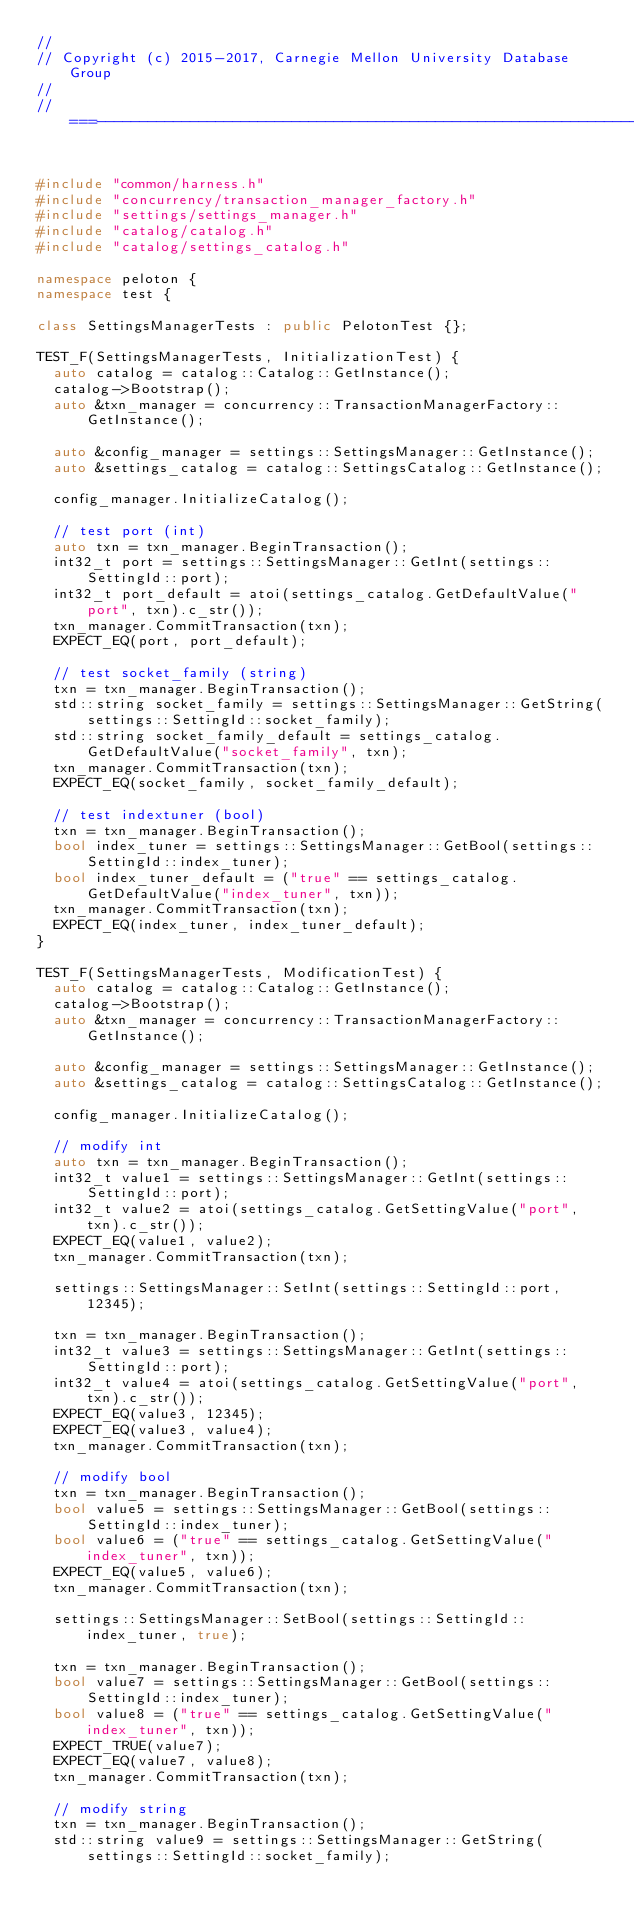<code> <loc_0><loc_0><loc_500><loc_500><_C++_>//
// Copyright (c) 2015-2017, Carnegie Mellon University Database Group
//
//===----------------------------------------------------------------------===//


#include "common/harness.h"
#include "concurrency/transaction_manager_factory.h"
#include "settings/settings_manager.h"
#include "catalog/catalog.h"
#include "catalog/settings_catalog.h"

namespace peloton {
namespace test {

class SettingsManagerTests : public PelotonTest {};

TEST_F(SettingsManagerTests, InitializationTest) {
  auto catalog = catalog::Catalog::GetInstance();
  catalog->Bootstrap();
  auto &txn_manager = concurrency::TransactionManagerFactory::GetInstance();

  auto &config_manager = settings::SettingsManager::GetInstance();
  auto &settings_catalog = catalog::SettingsCatalog::GetInstance();

  config_manager.InitializeCatalog();

  // test port (int)
  auto txn = txn_manager.BeginTransaction();
  int32_t port = settings::SettingsManager::GetInt(settings::SettingId::port);
  int32_t port_default = atoi(settings_catalog.GetDefaultValue("port", txn).c_str());
  txn_manager.CommitTransaction(txn);
  EXPECT_EQ(port, port_default);

  // test socket_family (string)
  txn = txn_manager.BeginTransaction();
  std::string socket_family = settings::SettingsManager::GetString(settings::SettingId::socket_family);
  std::string socket_family_default = settings_catalog.GetDefaultValue("socket_family", txn);
  txn_manager.CommitTransaction(txn);
  EXPECT_EQ(socket_family, socket_family_default);

  // test indextuner (bool)
  txn = txn_manager.BeginTransaction();
  bool index_tuner = settings::SettingsManager::GetBool(settings::SettingId::index_tuner);
  bool index_tuner_default = ("true" == settings_catalog.GetDefaultValue("index_tuner", txn));
  txn_manager.CommitTransaction(txn);
  EXPECT_EQ(index_tuner, index_tuner_default);
}

TEST_F(SettingsManagerTests, ModificationTest) {
  auto catalog = catalog::Catalog::GetInstance();
  catalog->Bootstrap();
  auto &txn_manager = concurrency::TransactionManagerFactory::GetInstance();

  auto &config_manager = settings::SettingsManager::GetInstance();
  auto &settings_catalog = catalog::SettingsCatalog::GetInstance();

  config_manager.InitializeCatalog();

  // modify int
  auto txn = txn_manager.BeginTransaction();
  int32_t value1 = settings::SettingsManager::GetInt(settings::SettingId::port);
  int32_t value2 = atoi(settings_catalog.GetSettingValue("port", txn).c_str());
  EXPECT_EQ(value1, value2);
  txn_manager.CommitTransaction(txn);

  settings::SettingsManager::SetInt(settings::SettingId::port, 12345);

  txn = txn_manager.BeginTransaction();
  int32_t value3 = settings::SettingsManager::GetInt(settings::SettingId::port);
  int32_t value4 = atoi(settings_catalog.GetSettingValue("port", txn).c_str());
  EXPECT_EQ(value3, 12345);
  EXPECT_EQ(value3, value4);
  txn_manager.CommitTransaction(txn);

  // modify bool
  txn = txn_manager.BeginTransaction();
  bool value5 = settings::SettingsManager::GetBool(settings::SettingId::index_tuner);
  bool value6 = ("true" == settings_catalog.GetSettingValue("index_tuner", txn));
  EXPECT_EQ(value5, value6);
  txn_manager.CommitTransaction(txn);

  settings::SettingsManager::SetBool(settings::SettingId::index_tuner, true);

  txn = txn_manager.BeginTransaction();
  bool value7 = settings::SettingsManager::GetBool(settings::SettingId::index_tuner);
  bool value8 = ("true" == settings_catalog.GetSettingValue("index_tuner", txn));
  EXPECT_TRUE(value7);
  EXPECT_EQ(value7, value8);
  txn_manager.CommitTransaction(txn);

  // modify string
  txn = txn_manager.BeginTransaction();
  std::string value9 = settings::SettingsManager::GetString(settings::SettingId::socket_family);</code> 